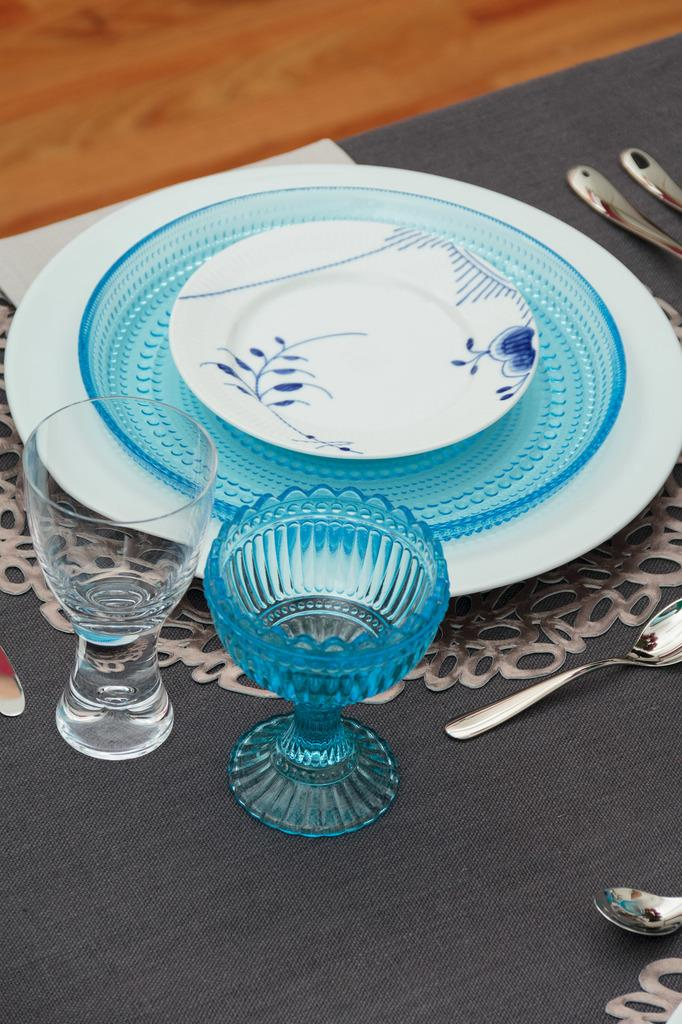What is present on the table in the image? There is a plate and two glasses in the image. What utensils can be seen beside the plate? There are spoons beside the plate. What can be seen in the background of the image? There is a wooden board in the background of the image. What type of twig is being used as a pen by the secretary in the image? There is no secretary or twig present in the image. What kind of stone is visible on the table in the image? There is no stone visible on the table in the image. 